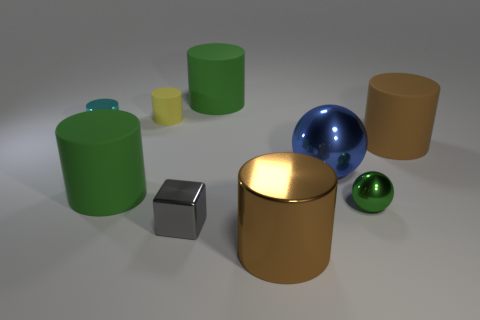Subtract 3 cylinders. How many cylinders are left? 3 Subtract all cyan cylinders. How many cylinders are left? 5 Subtract all green cylinders. How many cylinders are left? 4 Subtract all red cylinders. Subtract all green blocks. How many cylinders are left? 6 Add 1 small cyan shiny things. How many objects exist? 10 Subtract all blocks. How many objects are left? 8 Add 6 large matte cylinders. How many large matte cylinders are left? 9 Add 3 gray metal things. How many gray metal things exist? 4 Subtract 0 gray balls. How many objects are left? 9 Subtract all small matte cylinders. Subtract all cyan shiny objects. How many objects are left? 7 